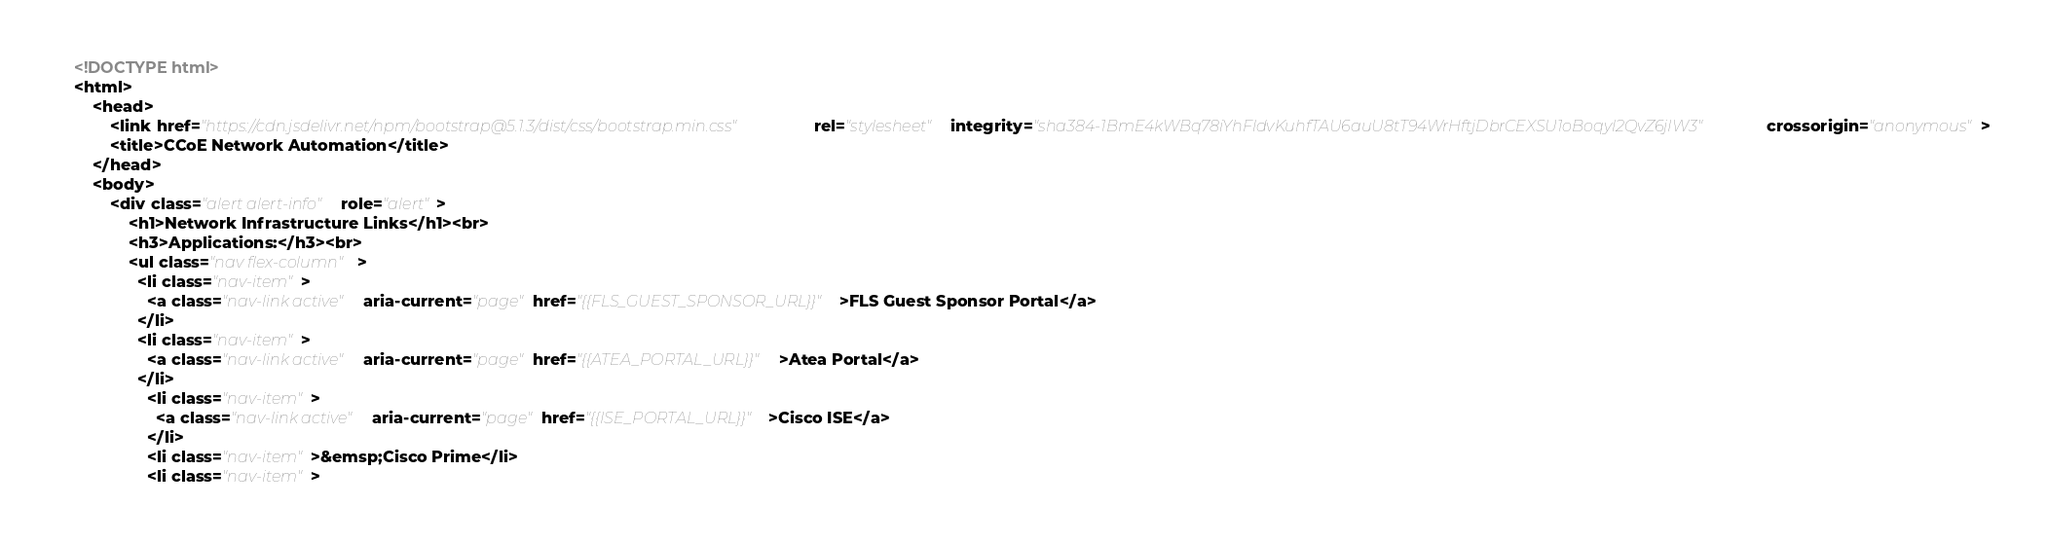Convert code to text. <code><loc_0><loc_0><loc_500><loc_500><_HTML_><!DOCTYPE html>
<html>
    <head>
        <link href="https://cdn.jsdelivr.net/npm/bootstrap@5.1.3/dist/css/bootstrap.min.css" rel="stylesheet" integrity="sha384-1BmE4kWBq78iYhFldvKuhfTAU6auU8tT94WrHftjDbrCEXSU1oBoqyl2QvZ6jIW3" crossorigin="anonymous">
        <title>CCoE Network Automation</title>
    </head>
    <body>
        <div class="alert alert-info" role="alert">
            <h1>Network Infrastructure Links</h1><br>
            <h3>Applications:</h3><br>
            <ul class="nav flex-column">
              <li class="nav-item">
                <a class="nav-link active" aria-current="page" href="{{FLS_GUEST_SPONSOR_URL}}">FLS Guest Sponsor Portal</a>
              </li>
              <li class="nav-item">
                <a class="nav-link active" aria-current="page" href="{{ATEA_PORTAL_URL}}">Atea Portal</a>
              </li>
                <li class="nav-item">
                  <a class="nav-link active" aria-current="page" href="{{ISE_PORTAL_URL}}">Cisco ISE</a>
                </li>
                <li class="nav-item">&emsp;Cisco Prime</li>
                <li class="nav-item"></code> 